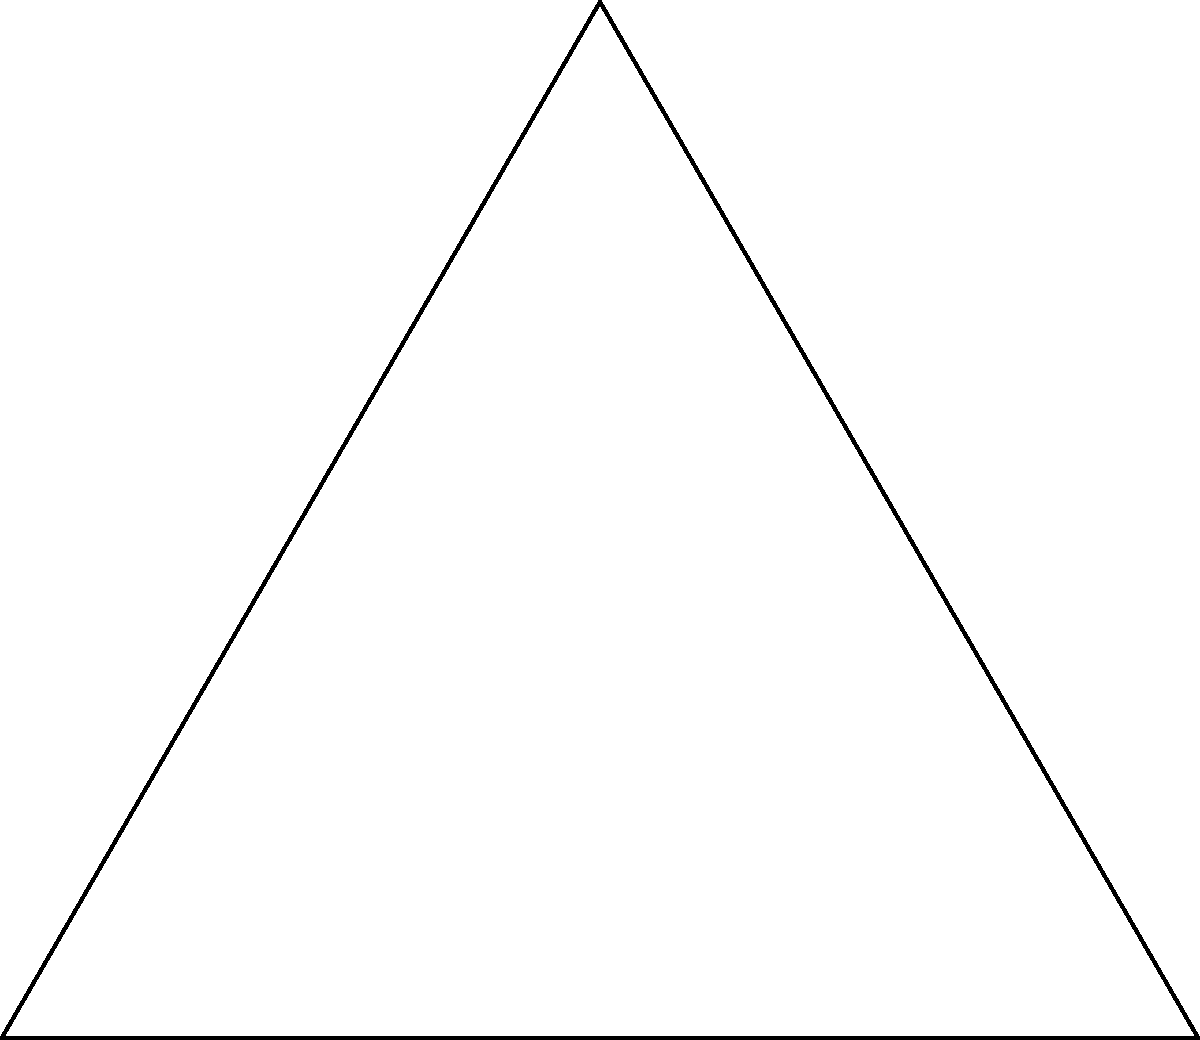In a theatrical production of "Geometry in Motion", the stage is set up as an equilateral triangle with colored spotlights at each vertex. A yellow spotlight is placed at the midpoint of the base. How many lines of symmetry does this stage layout have? Let's approach this step-by-step:

1) First, recall that an equilateral triangle has 3 lines of symmetry:
   - One from each vertex to the midpoint of the opposite side.

2) Now, let's consider the additional yellow spotlight:
   - It's placed at the midpoint of the base of the triangle.

3) This yellow spotlight affects the symmetry:
   - It eliminates two of the original lines of symmetry (those passing through the base vertices).
   - The only remaining line of symmetry is the one that passes through the top vertex and the yellow spotlight.

4) To verify:
   - If we fold along the line from the top vertex to the yellow spotlight, the left and right sides of the stage layout would perfectly align.
   - Any other fold would disrupt the symmetry due to the position of the yellow spotlight.

5) Therefore, this stage layout has only one line of symmetry.
Answer: 1 